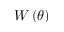<formula> <loc_0><loc_0><loc_500><loc_500>W \left ( \theta \right )</formula> 